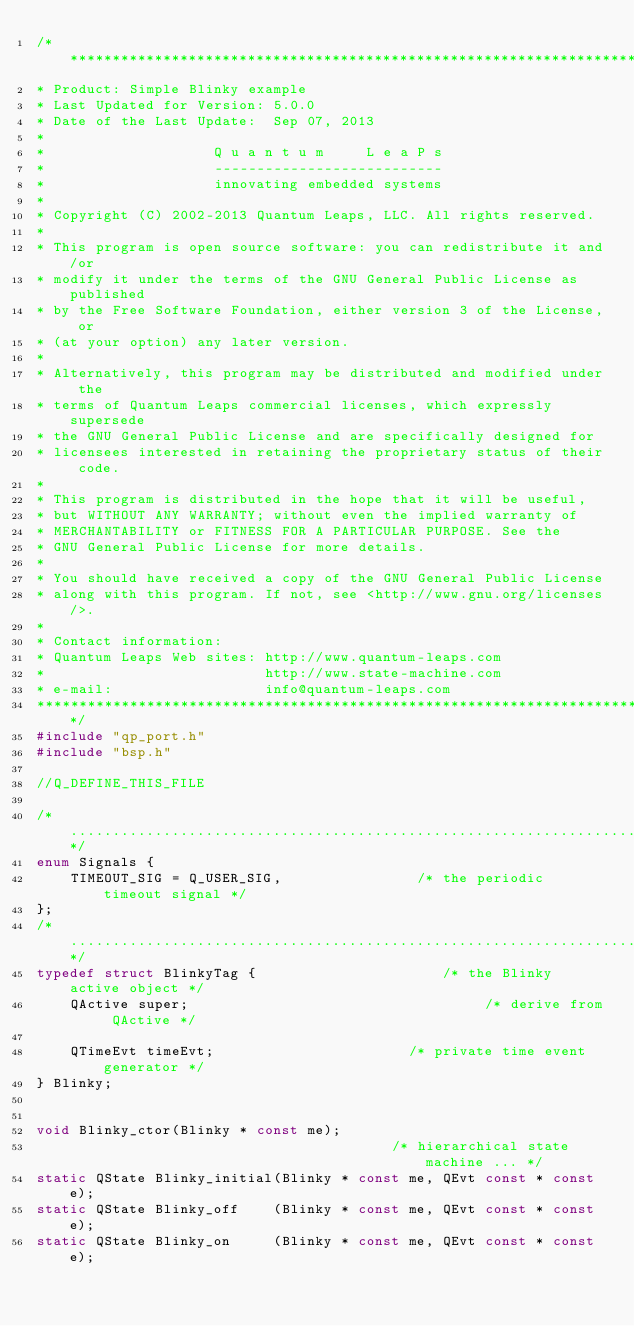<code> <loc_0><loc_0><loc_500><loc_500><_C_>/*****************************************************************************
* Product: Simple Blinky example
* Last Updated for Version: 5.0.0
* Date of the Last Update:  Sep 07, 2013
*
*                    Q u a n t u m     L e a P s
*                    ---------------------------
*                    innovating embedded systems
*
* Copyright (C) 2002-2013 Quantum Leaps, LLC. All rights reserved.
*
* This program is open source software: you can redistribute it and/or
* modify it under the terms of the GNU General Public License as published
* by the Free Software Foundation, either version 3 of the License, or
* (at your option) any later version.
*
* Alternatively, this program may be distributed and modified under the
* terms of Quantum Leaps commercial licenses, which expressly supersede
* the GNU General Public License and are specifically designed for
* licensees interested in retaining the proprietary status of their code.
*
* This program is distributed in the hope that it will be useful,
* but WITHOUT ANY WARRANTY; without even the implied warranty of
* MERCHANTABILITY or FITNESS FOR A PARTICULAR PURPOSE. See the
* GNU General Public License for more details.
*
* You should have received a copy of the GNU General Public License
* along with this program. If not, see <http://www.gnu.org/licenses/>.
*
* Contact information:
* Quantum Leaps Web sites: http://www.quantum-leaps.com
*                          http://www.state-machine.com
* e-mail:                  info@quantum-leaps.com
*****************************************************************************/
#include "qp_port.h"
#include "bsp.h"

//Q_DEFINE_THIS_FILE

/*..........................................................................*/
enum Signals {
    TIMEOUT_SIG = Q_USER_SIG,                /* the periodic timeout signal */
};
/*..........................................................................*/
typedef struct BlinkyTag {                      /* the Blinky active object */
    QActive super;                                   /* derive from QActive */

    QTimeEvt timeEvt;                       /* private time event generator */
} Blinky;


void Blinky_ctor(Blinky * const me);
                                          /* hierarchical state machine ... */
static QState Blinky_initial(Blinky * const me, QEvt const * const e);
static QState Blinky_off    (Blinky * const me, QEvt const * const e);
static QState Blinky_on     (Blinky * const me, QEvt const * const e);
</code> 